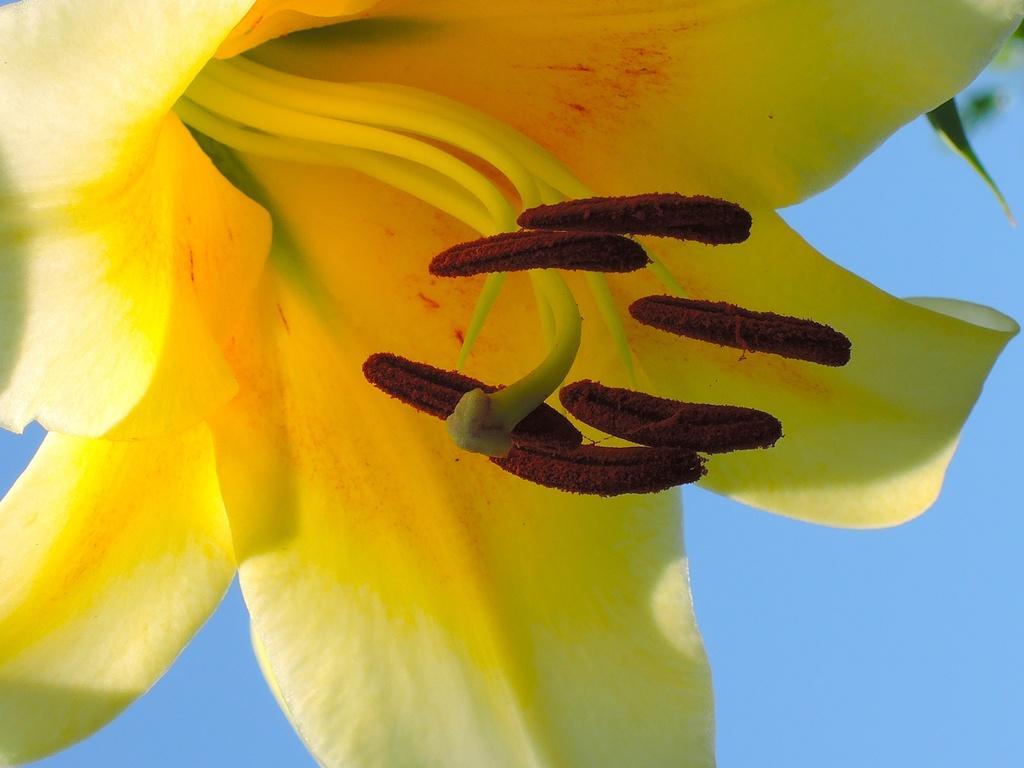Could you give a brief overview of what you see in this image? In this image we can see a flower. Behind the flower we can see the sky. 